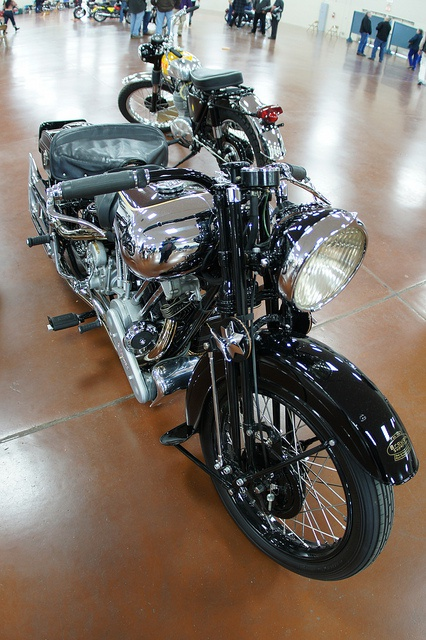Describe the objects in this image and their specific colors. I can see motorcycle in ivory, black, gray, darkgray, and lightgray tones, motorcycle in ivory, black, darkgray, lightgray, and gray tones, people in ivory, black, lightblue, and gray tones, people in ivory, black, blue, and navy tones, and people in ivory, black, gray, and lightblue tones in this image. 